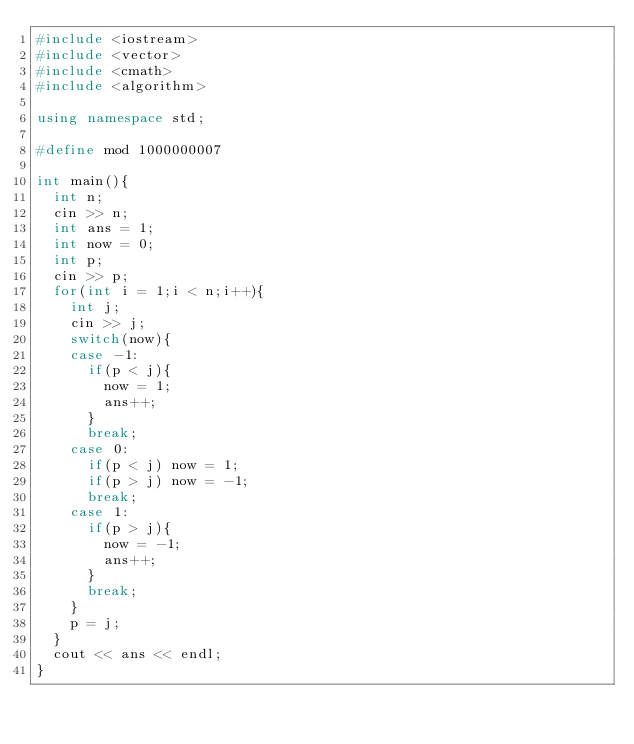<code> <loc_0><loc_0><loc_500><loc_500><_C++_>#include <iostream>
#include <vector>
#include <cmath>
#include <algorithm>

using namespace std;

#define mod 1000000007

int main(){
	int n;
	cin >> n;
	int ans = 1;
	int now = 0;
	int p;
	cin >> p;
	for(int i = 1;i < n;i++){
		int j;
		cin >> j;
		switch(now){
		case -1:
			if(p < j){
				now = 1;
				ans++;
			}
			break;
		case 0:
			if(p < j) now = 1;
			if(p > j) now = -1;
			break;
		case 1:
			if(p > j){
				now = -1;
				ans++;
			}
			break;
		}
		p = j;
	}
	cout << ans << endl;
}
</code> 